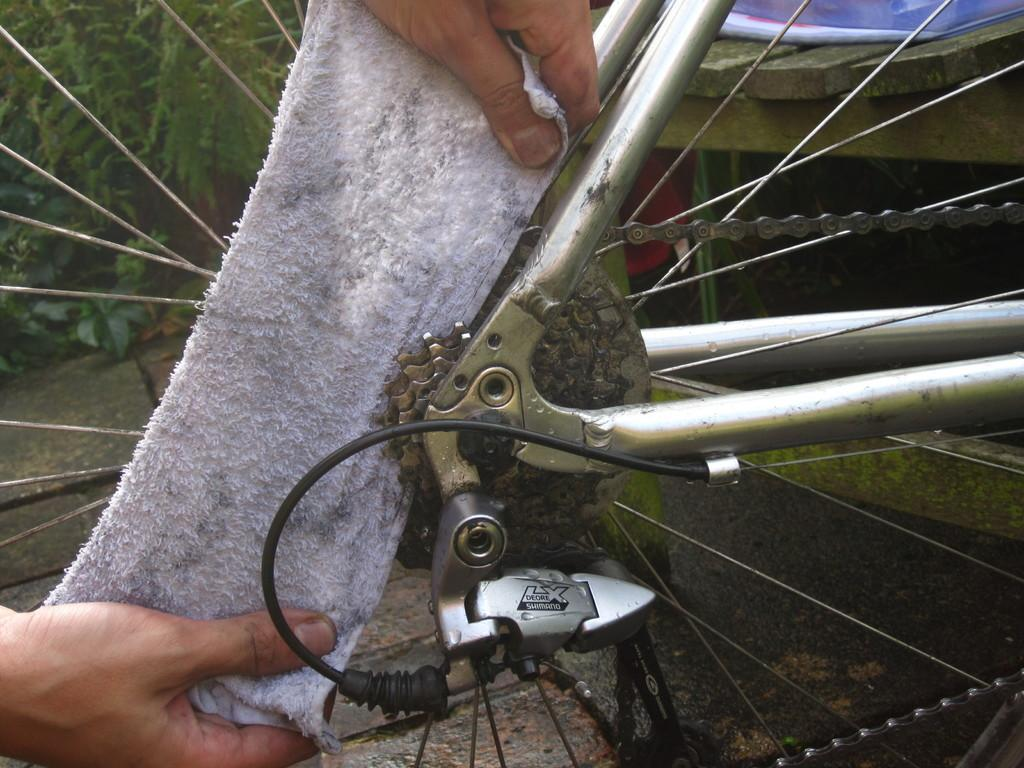What is the main object in the center of the image? There is a cycle wheel in the center of the image. What is attached to the cycle wheel? The cycle wheel has a chain. What is placed next to the cycle wheel in the center of the image? There is a napkin in the center of the image. What can be seen in the background of the image? There are trees and a bench in the background of the image. Can you see any dolls attempting to swim in the lake in the image? There is no lake or dolls present in the image. 